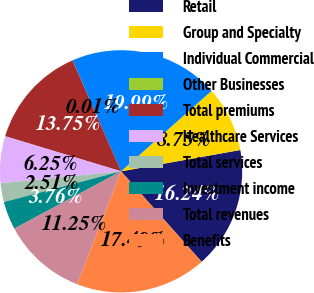<chart> <loc_0><loc_0><loc_500><loc_500><pie_chart><fcel>Retail<fcel>Group and Specialty<fcel>Individual Commercial<fcel>Other Businesses<fcel>Total premiums<fcel>Healthcare Services<fcel>Total services<fcel>Investment income<fcel>Total revenues<fcel>Benefits<nl><fcel>16.24%<fcel>8.75%<fcel>19.99%<fcel>0.01%<fcel>13.75%<fcel>6.25%<fcel>2.51%<fcel>3.76%<fcel>11.25%<fcel>17.49%<nl></chart> 